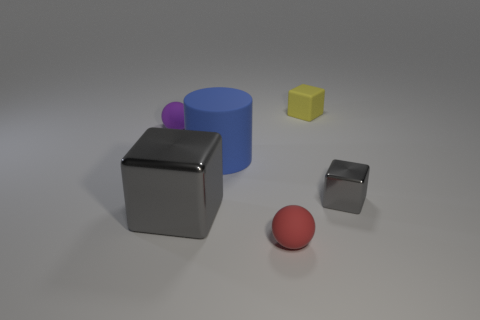Add 4 tiny red spheres. How many objects exist? 10 Subtract all cylinders. How many objects are left? 5 Subtract all tiny purple things. Subtract all small cubes. How many objects are left? 3 Add 2 tiny purple balls. How many tiny purple balls are left? 3 Add 6 tiny purple things. How many tiny purple things exist? 7 Subtract 0 gray balls. How many objects are left? 6 